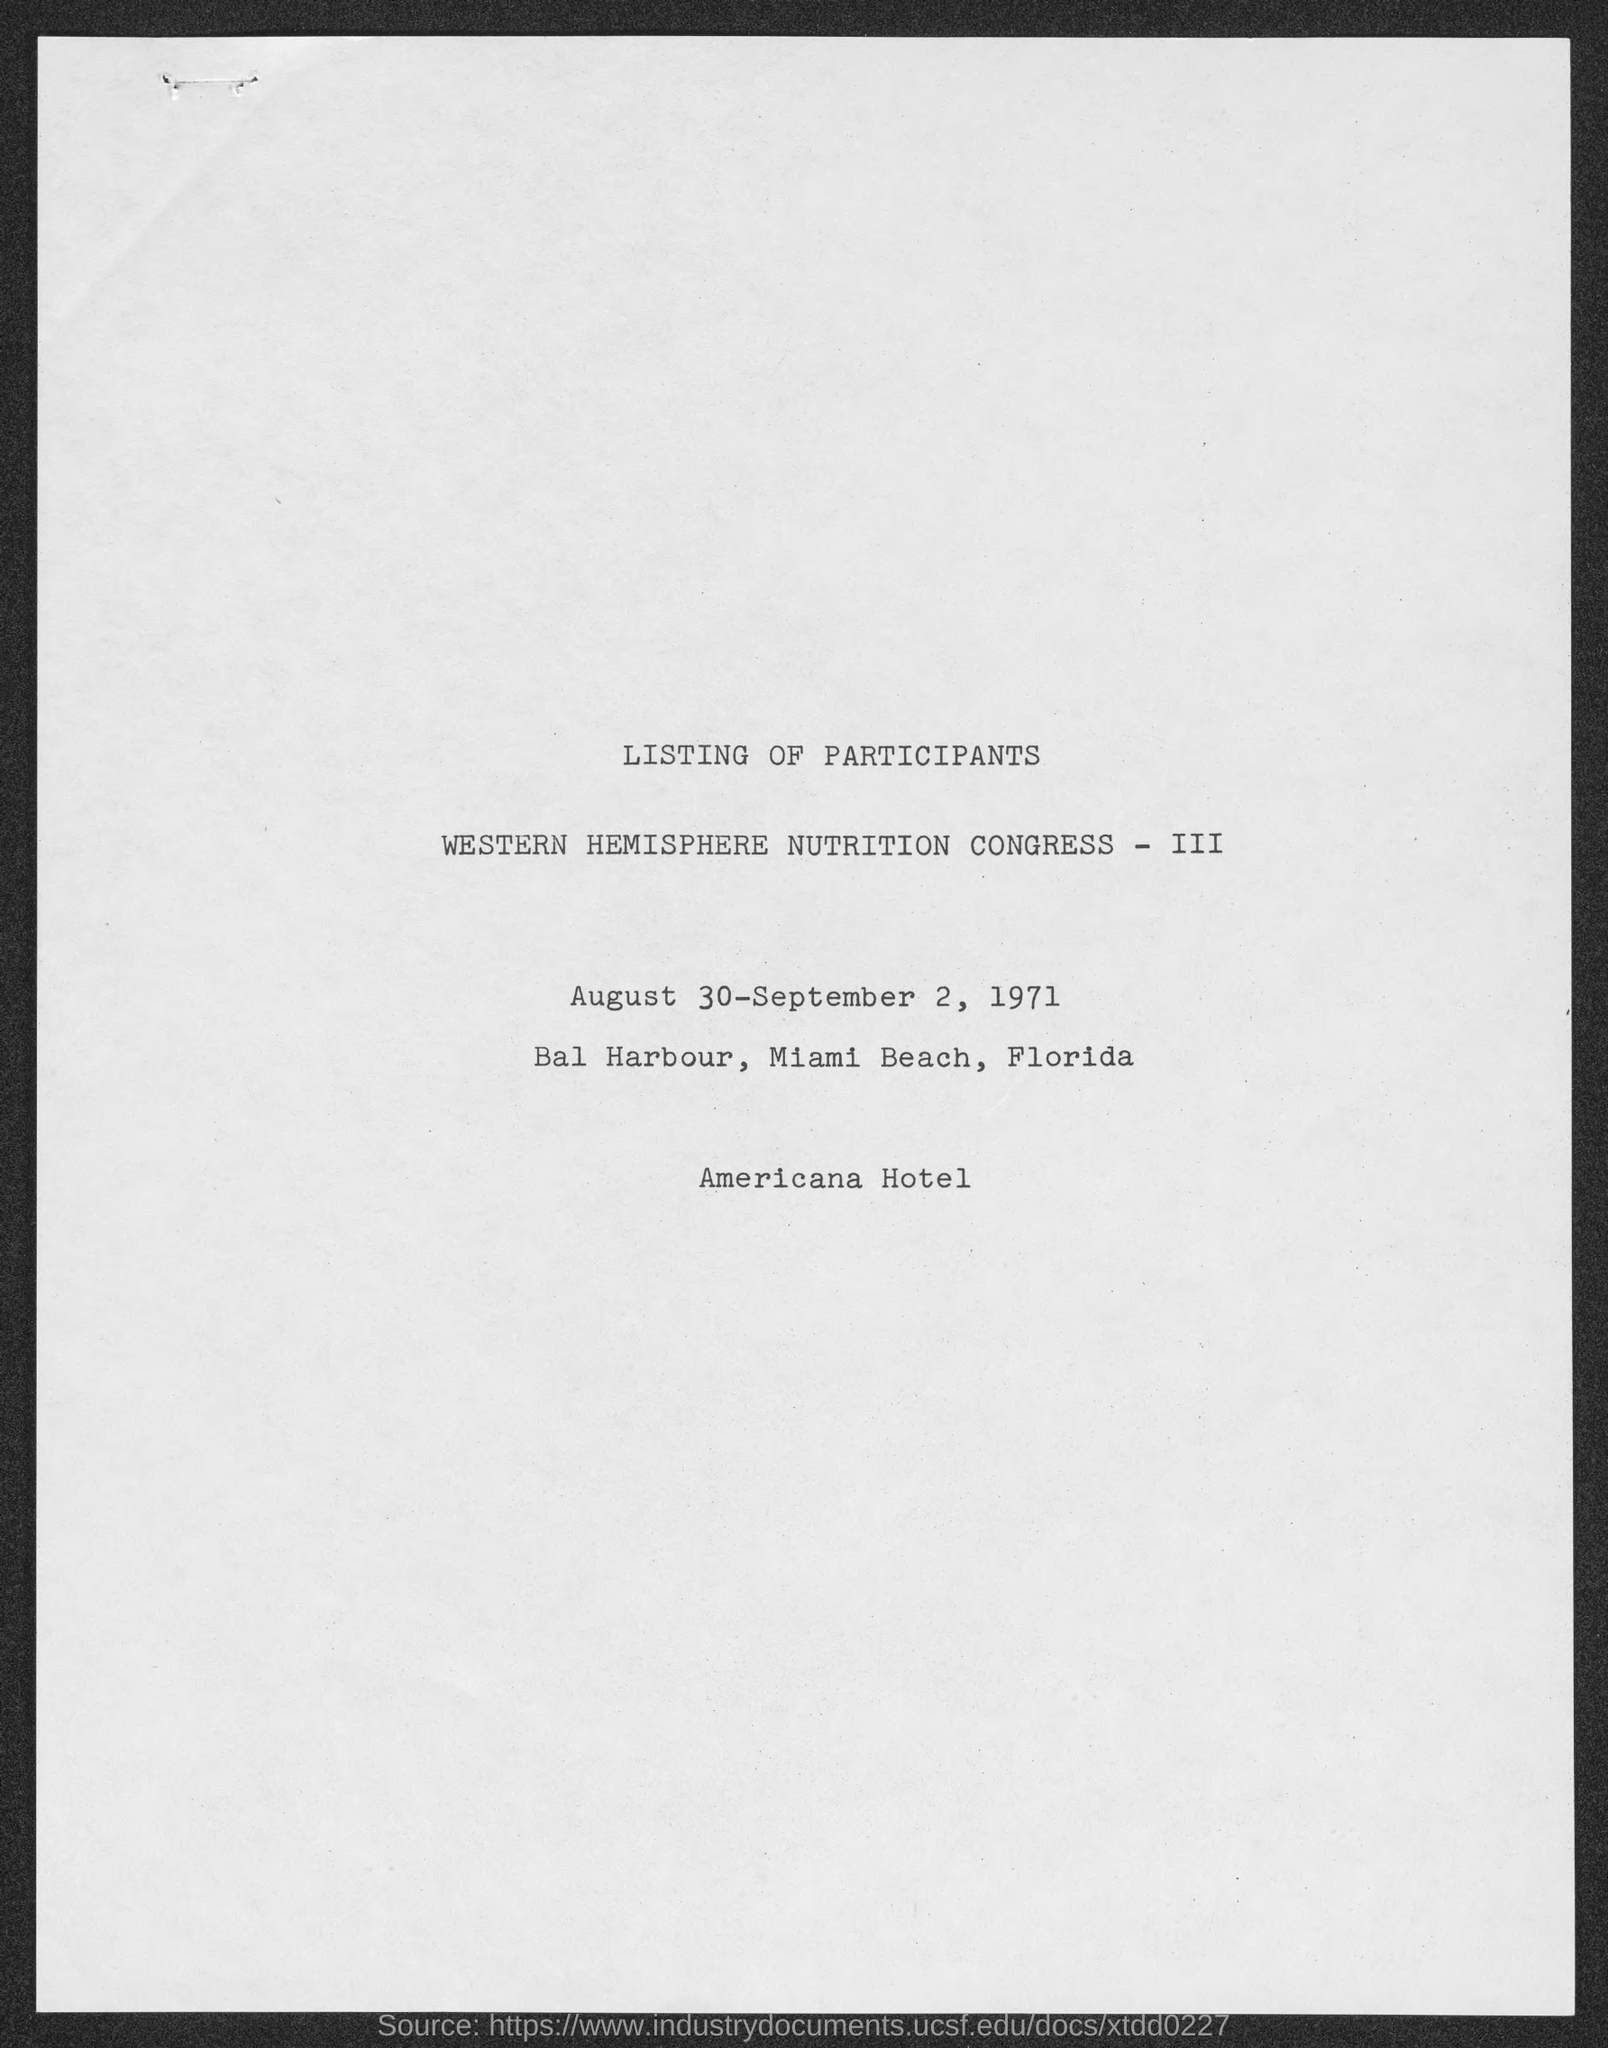Whose "LISTING" is mentioned in first line?
Your answer should be compact. LISTING OF PARTICIPANTS. What is the event name mentioned in the second line?
Offer a very short reply. WESTERN HEMISPHERE NUTRITION CONGRESS - III. "WESTERN HEMISPHERE NUTRITION CONGRESS - III" will be conducted on which all dates?
Ensure brevity in your answer.  August 30-september 2, 1971. Provide the venue of "WESTERN HEMISPHERE NUTRITION CONGRESS - III"?
Your response must be concise. Bal harbour, miami beach, florida. Which "Hotel" name is mentioned in the last line?
Offer a very short reply. Americana Hotel. 